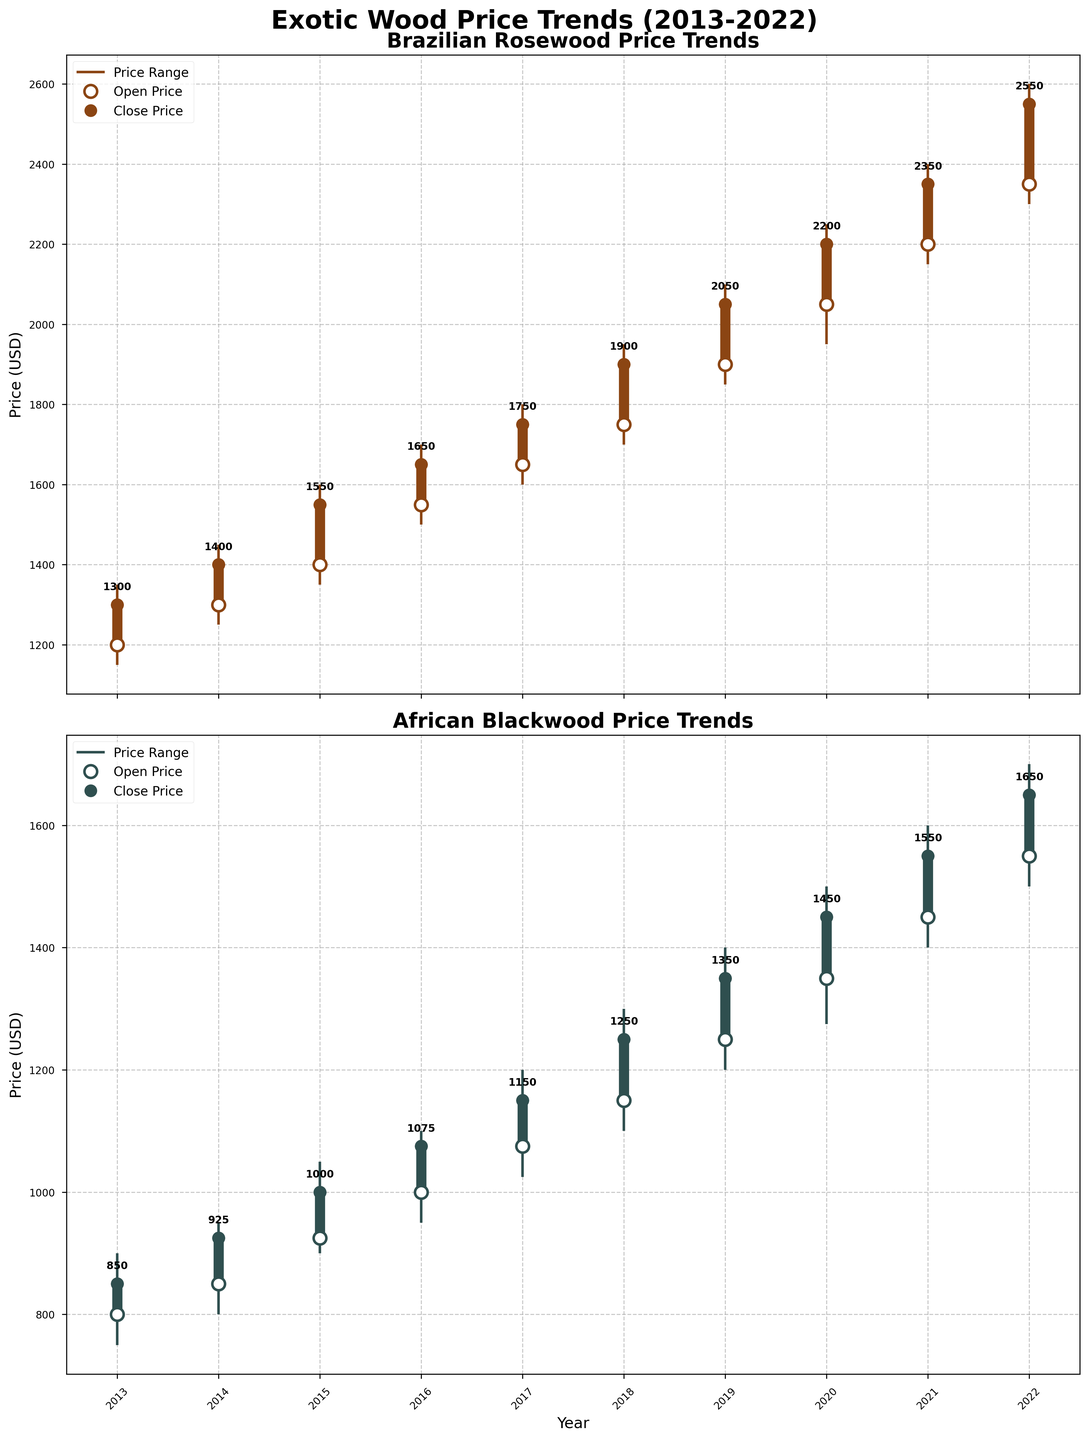what is the price range of Brazilian Rosewood in 2015? The price range is determined by the lowest and highest prices of the year. For Brazilian Rosewood in 2015, the lowest price is 1350 USD and the highest price is 1600 USD.
Answer: 1350-1600 USD Which year shows the highest closing price for African Blackwood? To determine the highest closing price, compare the closing prices of all years for African Blackwood. The year 2022 has the highest closing price of 1650 USD for African Blackwood.
Answer: 2022 What's the difference between the opening and closing prices of Brazilian Rosewood in 2020? The opening price for Brazilian Rosewood in 2020 is 2050 USD and the closing price is 2200 USD. The difference can be calculated as 2200 - 2050 = 150 USD.
Answer: 150 USD Which wood species had a higher peak price in 2019, and what was the difference? Compare the peak prices for both species in 2019. Brazilian Rosewood's peak price is 2100 USD and African Blackwood's peak price is 1400 USD. The difference is 2100 - 1400 = 700 USD.
Answer: Brazilian Rosewood, 700 USD What trend do you notice about the opening prices of both wood species from 2013 to 2020? Observing the plot, both wood species show a generally increasing trend in their opening prices from 2013 to 2020. Brazilian Rosewood's opening price goes from 1200 to 2050 USD, while African Blackwood's opening price goes from 800 to 1350 USD.
Answer: Increasing trend Between 2017 and 2018, which wood species had a greater increase in closing prices? To determine the greater increase, find the difference between the closing prices of 2017 and 2018 for both species. Brazilian Rosewood goes from 1750 to 1900 USD, an increase of 150 USD. African Blackwood goes from 1150 to 1250 USD, an increase of 100 USD. Thus, Brazilian Rosewood had a greater increase.
Answer: Brazilian Rosewood What’s the median closing price of Brazilian Rosewood over the decade? To find the median, list the closing prices in ascending order: 1300, 1400, 1550, 1650, 1750, 1900, 2050, 2200, 2350, 2550. The median is the average of 5th and 6th values: (1750 + 1900)/2 = 1825 USD.
Answer: 1825 USD What is the average peak price of African Blackwood from 2013 to 2017? Sum the peak prices from 2013 to 2017 for African Blackwood: 900 + 950 + 1050 + 1100 + 1200 = 5200. Then divide by the number of years (5). The average peak price is 5200/5 = 1040 USD.
Answer: 1040 USD 